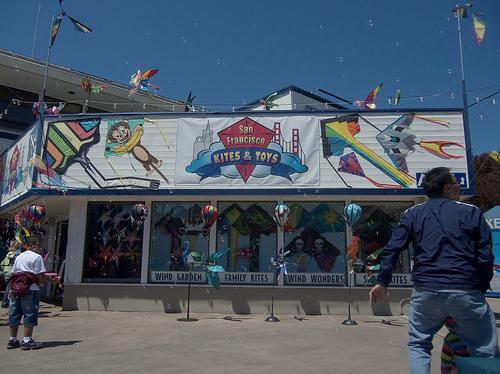How many people can be seen?
Give a very brief answer. 4. 